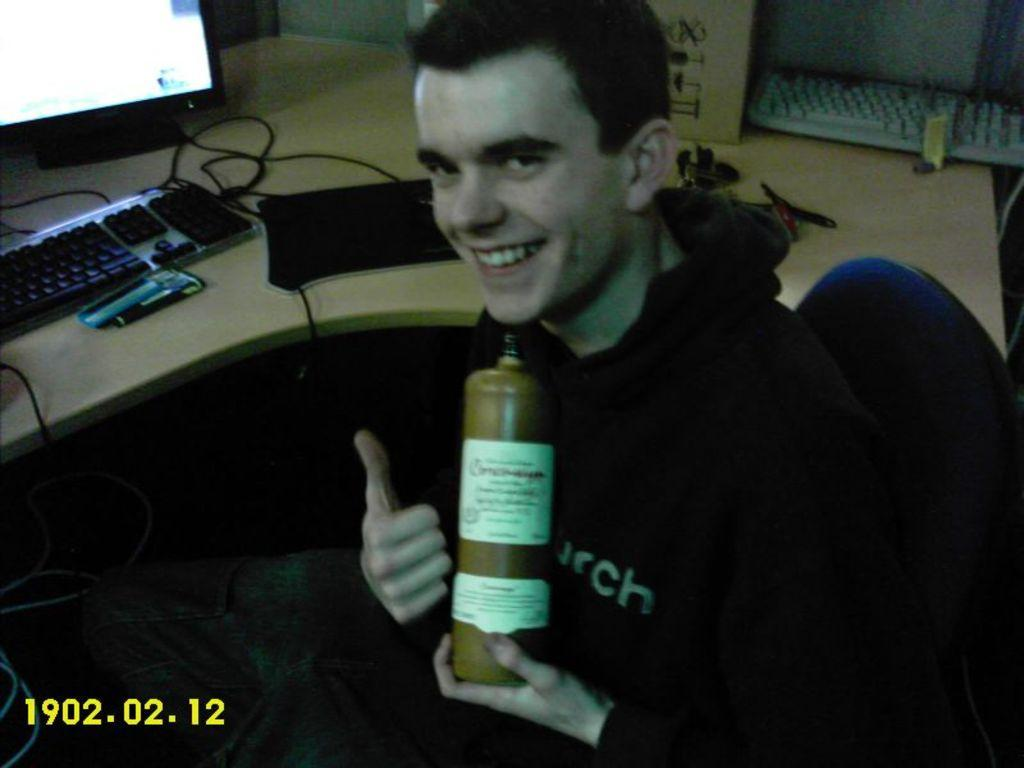Who is present in the image? There is a man in the image. What is the man doing in the image? The man is seated on a chair in the image. What is the man holding in his hand? The man is holding a bottle in his hand. What can be seen on the table in the image? There is a computer on a table in the image. What type of muscle can be seen flexing in the image? There is no muscle flexing visible in the image; it only shows a man seated on a chair holding a bottle. What kind of doll is sitting next to the computer in the image? There is no doll present in the image; it only shows a man seated on a chair holding a bottle and a computer on a table. 